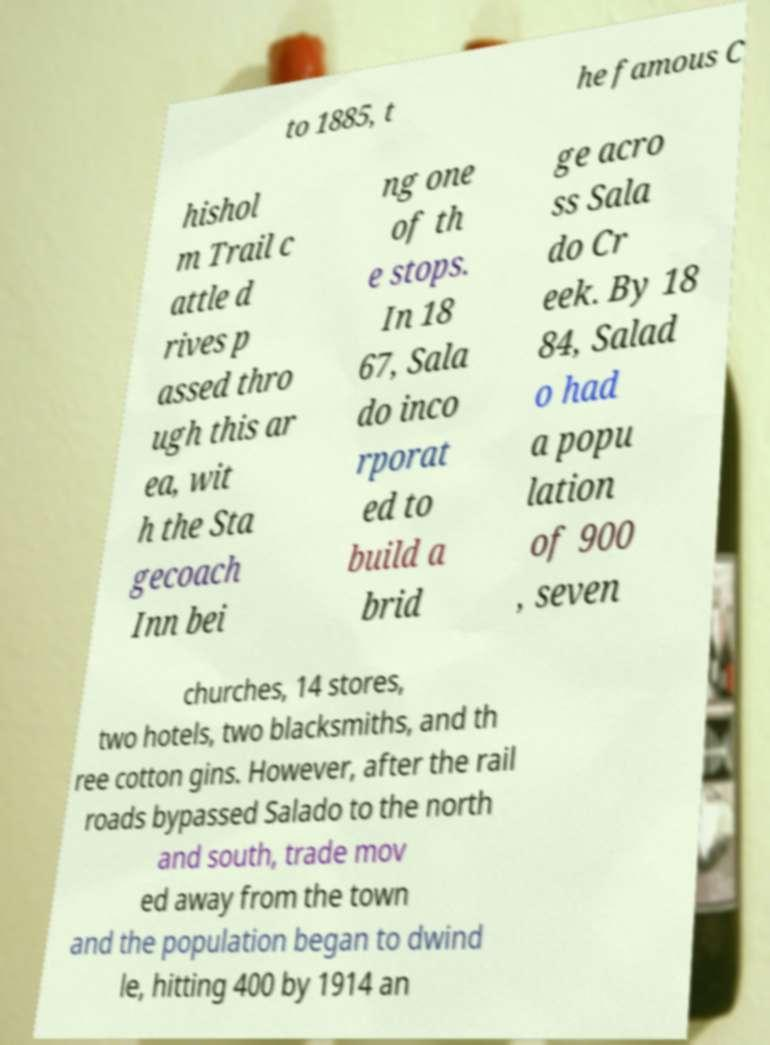Please identify and transcribe the text found in this image. to 1885, t he famous C hishol m Trail c attle d rives p assed thro ugh this ar ea, wit h the Sta gecoach Inn bei ng one of th e stops. In 18 67, Sala do inco rporat ed to build a brid ge acro ss Sala do Cr eek. By 18 84, Salad o had a popu lation of 900 , seven churches, 14 stores, two hotels, two blacksmiths, and th ree cotton gins. However, after the rail roads bypassed Salado to the north and south, trade mov ed away from the town and the population began to dwind le, hitting 400 by 1914 an 